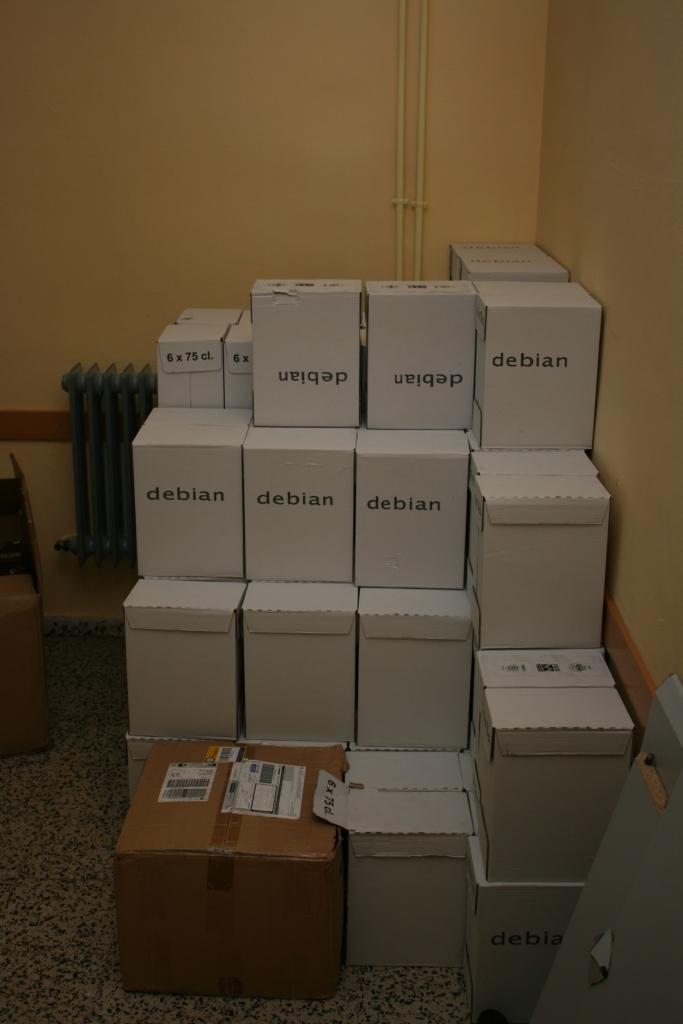What sweet is inside of the box?
Provide a succinct answer. Debian. What is the brand name on the stacked boxes?
Offer a terse response. Debian. 